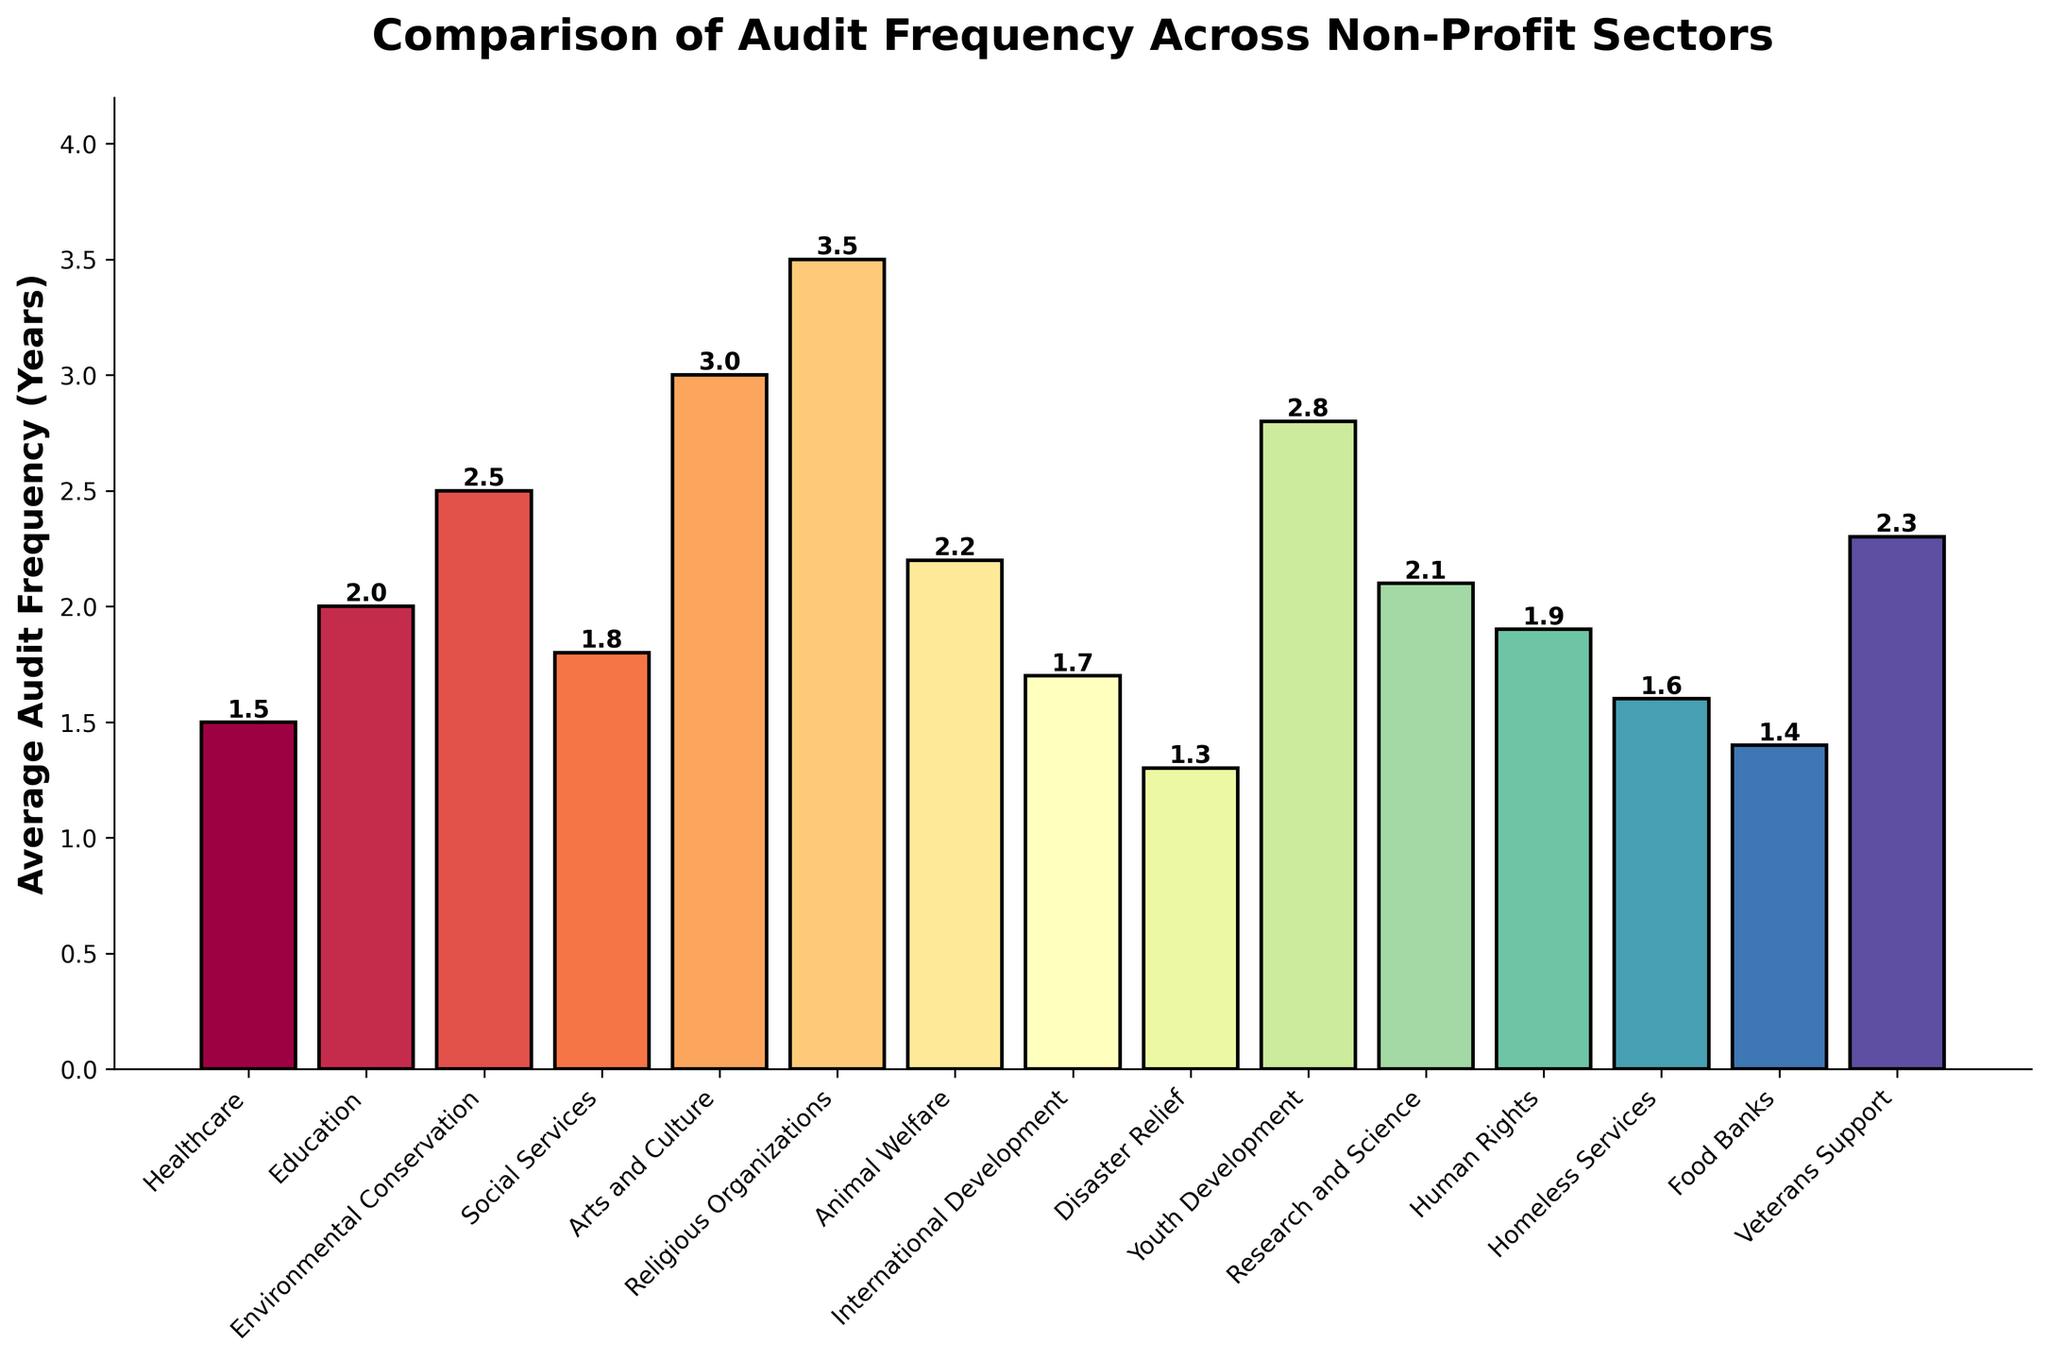What is the sector with the highest average audit frequency? The highest average audit frequency is determined by observing the tallest bar in the figure. The bar for "Disaster Relief" is the tallest, indicating the highest frequency.
Answer: Disaster Relief Which two sectors have the closest average audit frequencies? By comparing the heights of the bars, the sectors "Social Services" (1.8 years) and "Human Rights" (1.9 years) have close values. The difference in their heights is minimal.
Answer: Social Services and Human Rights What is the average audit frequency for sectors with less than 2 years? The sectors with frequencies less than 2 years are Healthcare (1.5), Social Services (1.8), Disaster Relief (1.3), International Development (1.7), Homeless Services (1.6), Food Banks (1.4), and Human Rights (1.9). The sum is (1.5 + 1.8 + 1.3 + 1.7 + 1.6 + 1.4 + 1.9) = 11.2, and the average is 11.2 / 7 ≈ 1.6 years.
Answer: 1.6 years Which sector's audit frequency is nearly twice that of the Disaster Relief sector? Disaster Relief has an average audit frequency of 1.3 years. Nearly twice this value is 1.3 * 2 ≈ 2.6 years. The "Environmental Conservation" sector has a value close to this at 2.5 years.
Answer: Environmental Conservation Are there more sectors with an average audit frequency above or below 2 years? Counting the bars, sectors below 2 years are 8 (Healthcare, Social Services, Disaster Relief, International Development, Homeless Services, Food Banks, Human Rights, and Animal Welfare), and those above 2 years are 7. There are more sectors below 2 years.
Answer: Below Which sector requires audits most frequently? The sector with the shortest bar, representing the shortest audit frequency in years, is "Disaster Relief" with 1.3 years.
Answer: Disaster Relief How does the average audit frequency for "Arts and Culture" compare to "Education"? "Arts and Culture" has a higher average audit frequency (3.0 years) compared to "Education" (2.0 years). The difference is 3.0 - 2.0 = 1.0 years.
Answer: Arts and Culture is 1 year higher than Education Which sector has a visually striking bar color, and what is its average audit frequency? The visually striking bar color (e.g., bright or different from others) could vary in perception, but the "Religious Organizations" bar color stands out, and its average audit frequency is 3.5 years.
Answer: Religious Organizations, 3.5 years What is the total number of sectors analyzed in the figure? Counting all the bars in the chart, we can see that there are 15 sectors in total.
Answer: 15 